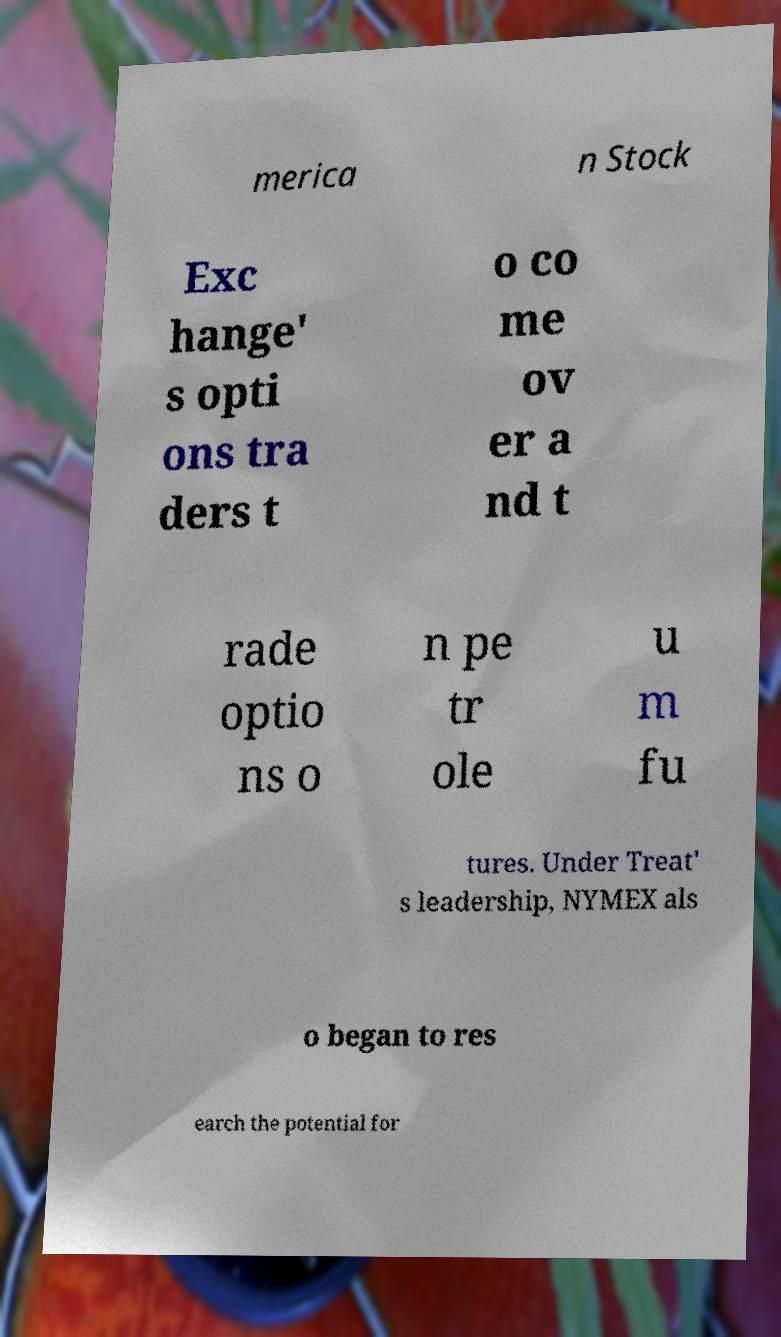Could you assist in decoding the text presented in this image and type it out clearly? merica n Stock Exc hange' s opti ons tra ders t o co me ov er a nd t rade optio ns o n pe tr ole u m fu tures. Under Treat' s leadership, NYMEX als o began to res earch the potential for 